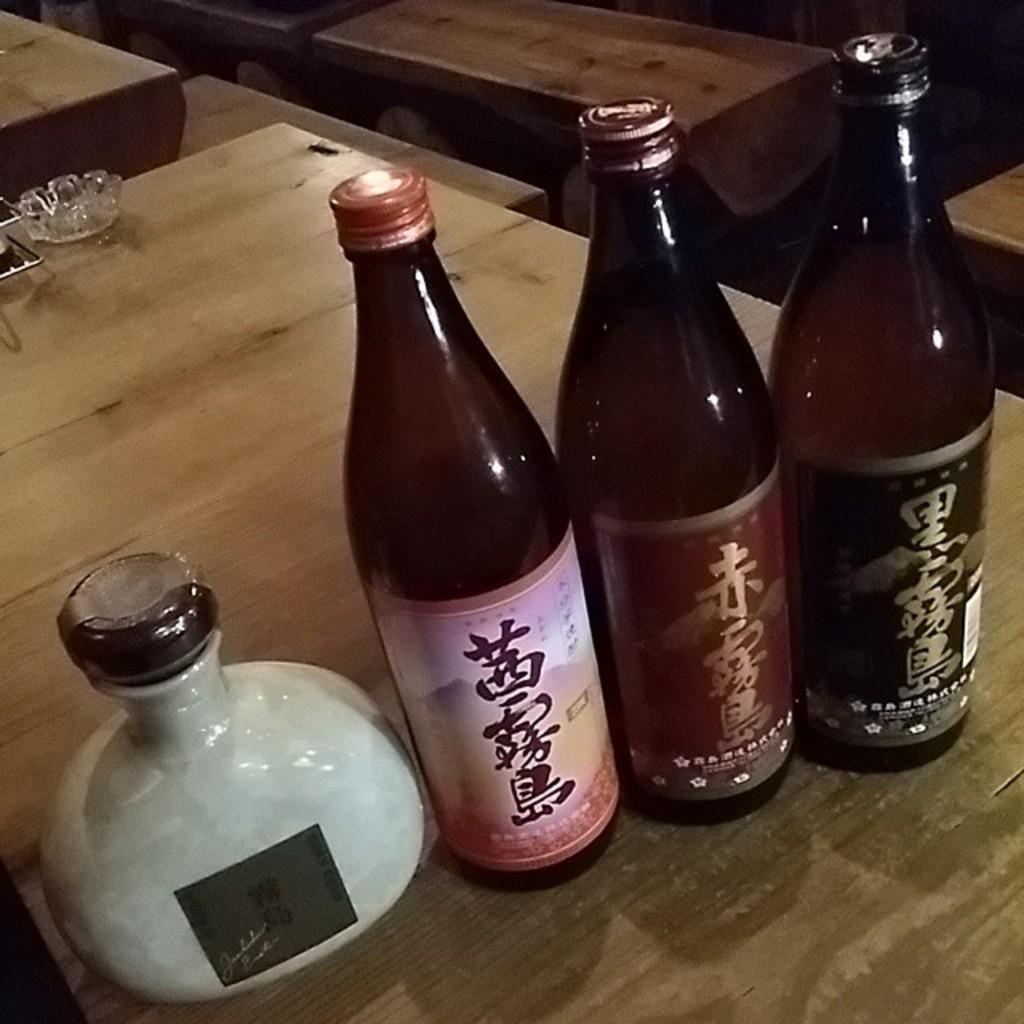What objects are on the table in the image? There are bottles on a table in the image. What type of furniture can be seen in the background of the image? There are tables and chairs in the background of the image. What type of pen is being used to write on the gate in the image? There is no pen or gate present in the image; it only features bottles on a table and tables and chairs in the background. 